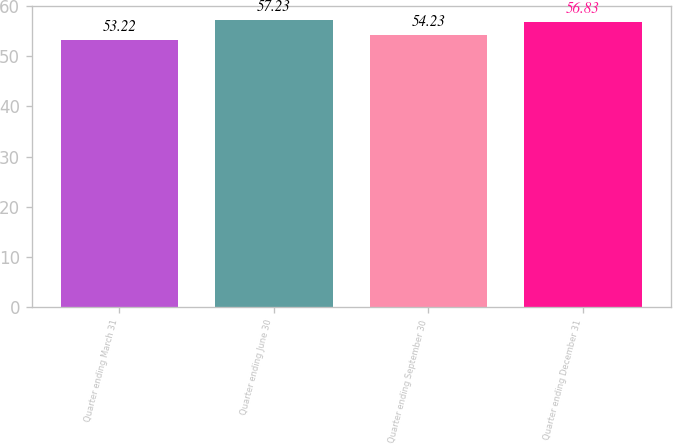Convert chart to OTSL. <chart><loc_0><loc_0><loc_500><loc_500><bar_chart><fcel>Quarter ending March 31<fcel>Quarter ending June 30<fcel>Quarter ending September 30<fcel>Quarter ending December 31<nl><fcel>53.22<fcel>57.23<fcel>54.23<fcel>56.83<nl></chart> 